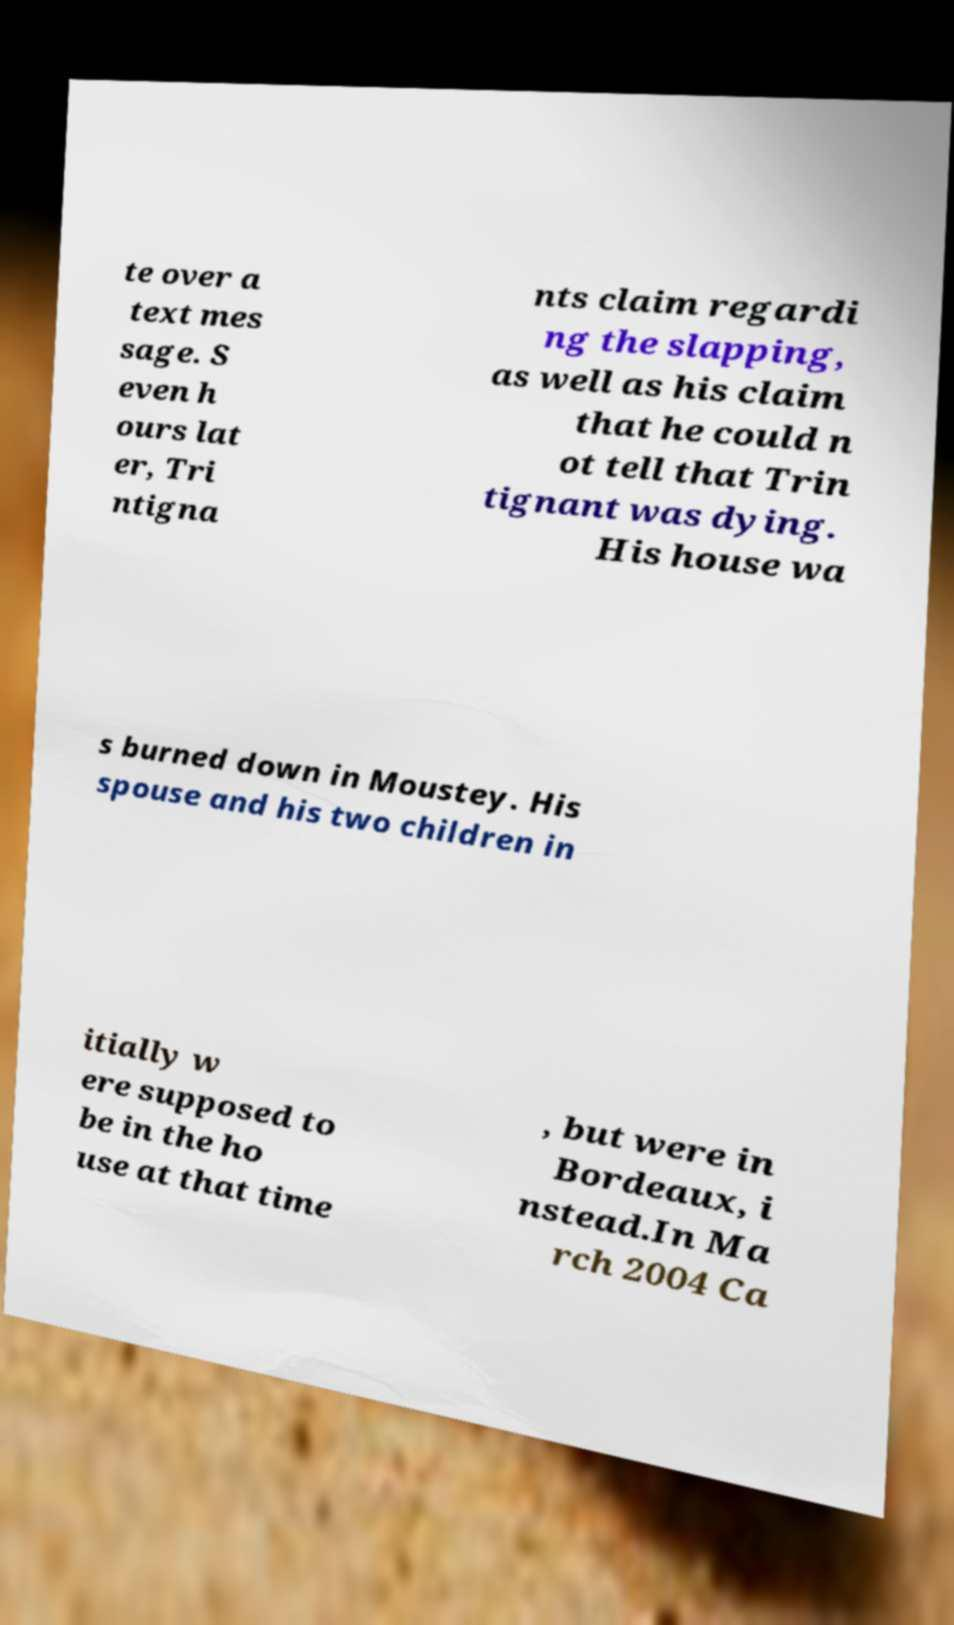Can you read and provide the text displayed in the image?This photo seems to have some interesting text. Can you extract and type it out for me? te over a text mes sage. S even h ours lat er, Tri ntigna nts claim regardi ng the slapping, as well as his claim that he could n ot tell that Trin tignant was dying. His house wa s burned down in Moustey. His spouse and his two children in itially w ere supposed to be in the ho use at that time , but were in Bordeaux, i nstead.In Ma rch 2004 Ca 